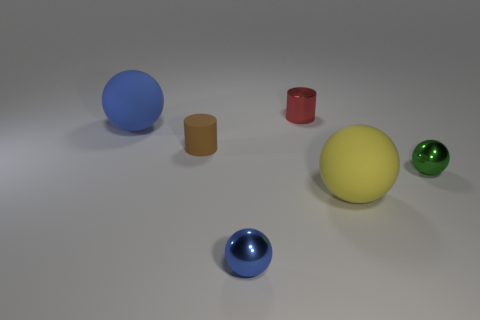There is a sphere that is behind the tiny thing to the left of the tiny shiny ball that is in front of the green ball; what size is it?
Offer a very short reply. Large. How many metallic things are either balls or red objects?
Your answer should be compact. 3. There is a red shiny object; does it have the same shape as the tiny thing left of the small blue metallic object?
Provide a succinct answer. Yes. Are there more big yellow matte things in front of the red metal thing than green things in front of the small blue sphere?
Offer a terse response. Yes. Are there any other things that have the same color as the tiny rubber thing?
Make the answer very short. No. There is a large object left of the blue object that is to the right of the brown rubber thing; are there any blue things in front of it?
Your response must be concise. Yes. There is a big thing that is behind the large yellow rubber thing; does it have the same shape as the tiny blue metallic thing?
Your answer should be compact. Yes. Are there fewer brown cylinders that are in front of the yellow matte thing than rubber balls behind the brown cylinder?
Provide a short and direct response. Yes. What is the big yellow object made of?
Provide a short and direct response. Rubber. There is a green metallic thing; how many red cylinders are in front of it?
Make the answer very short. 0. 